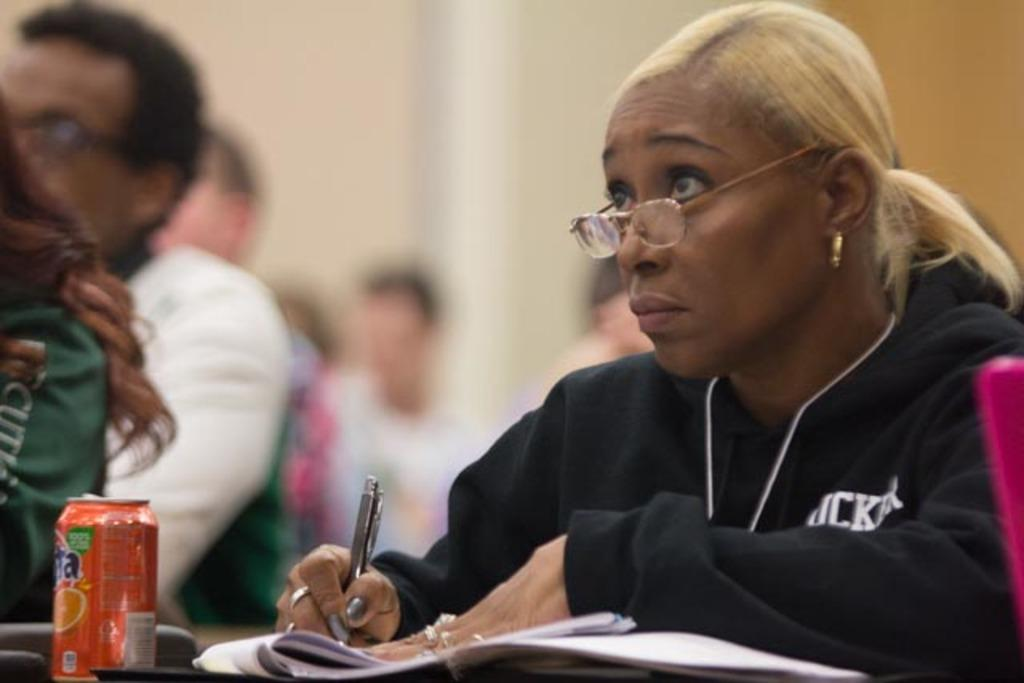What is the woman in the image doing? The woman is seated and writing on papers with a pen. What is the woman wearing in the image? The woman is wearing spectacles and a black jacket. What can be found on the table in the image? There is a can on the table. Are there other people in the image besides the woman? Yes, there are people seated in the image. What type of line can be seen connecting the houses in the image? There are no houses or lines connecting houses present in the image. 